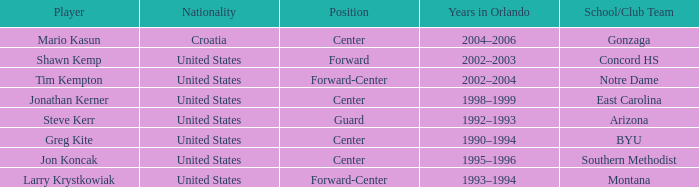Which participant has montana as their college/organization team? Larry Krystkowiak. 